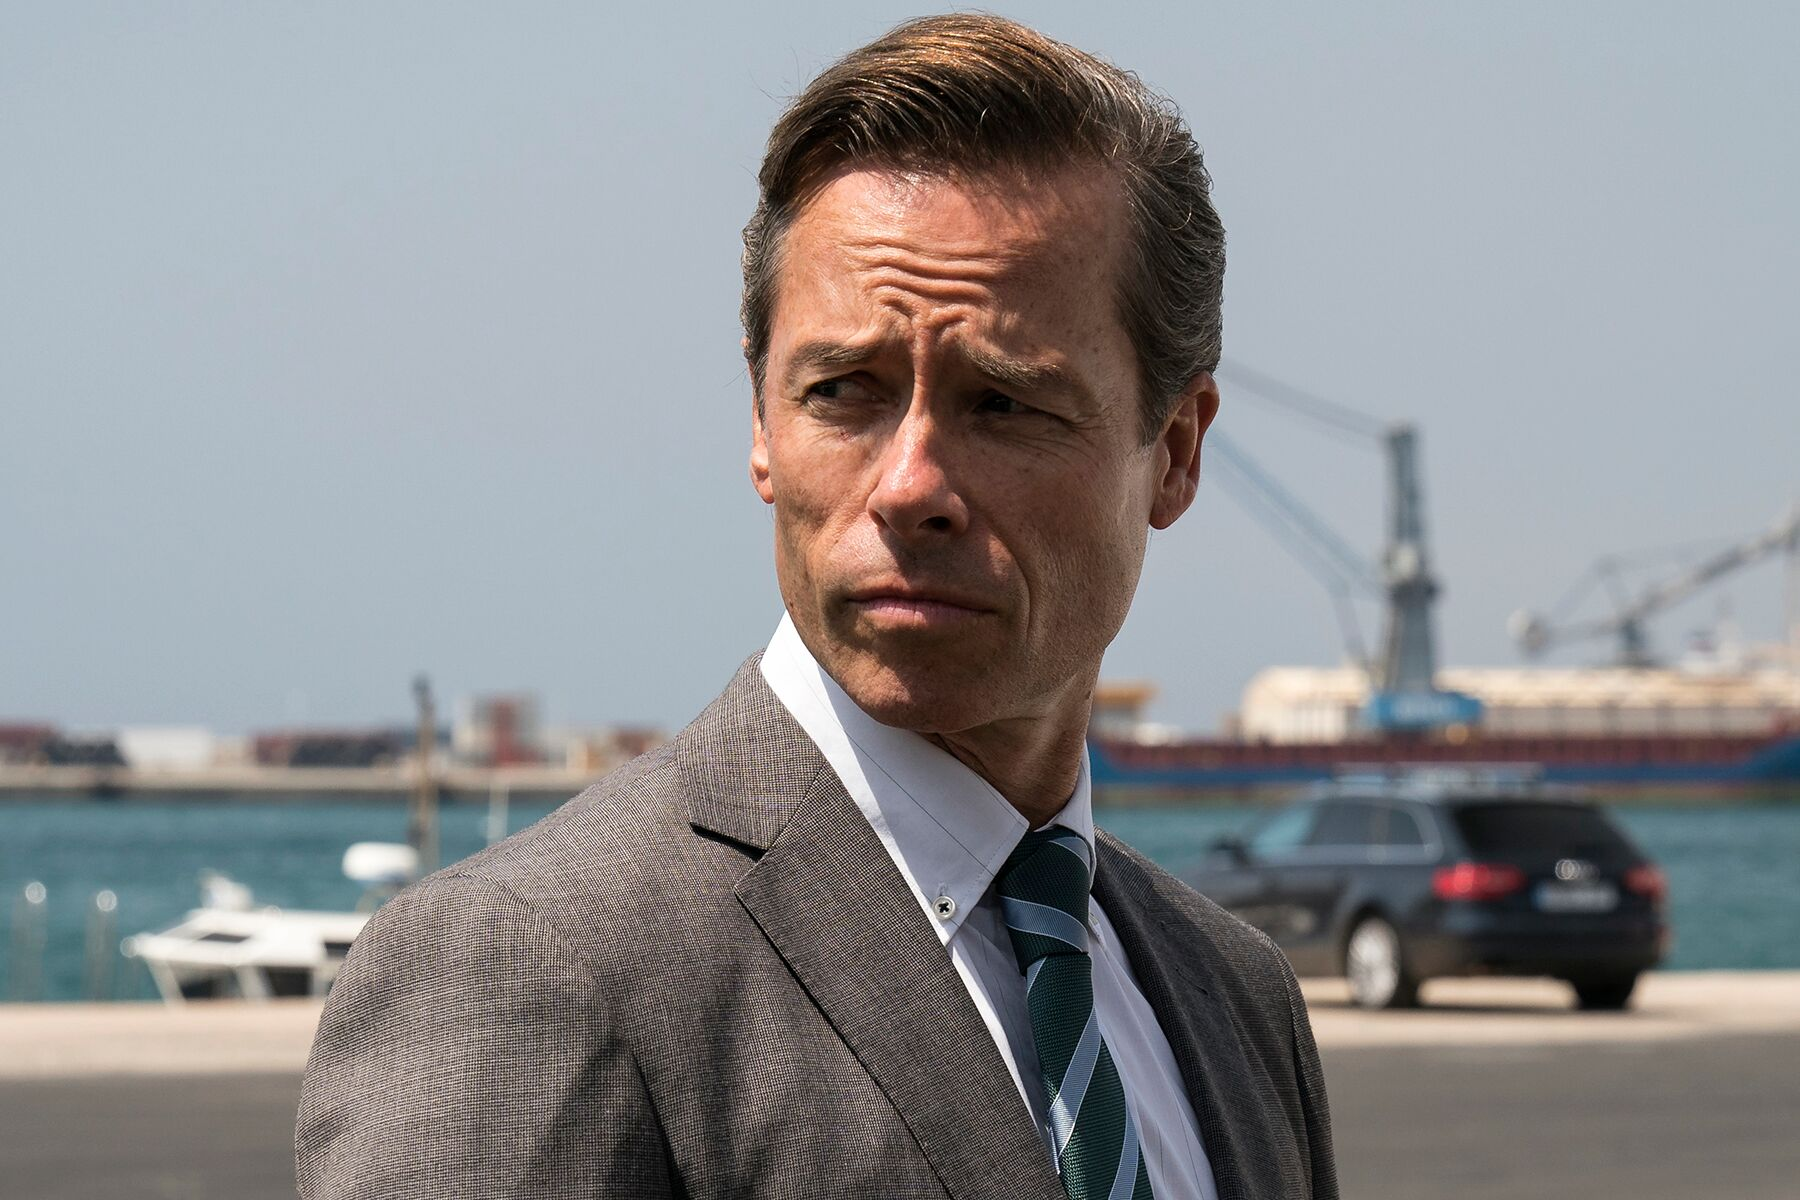Write a dialogue that could be happening in this scene. Assistant: "Sir, the shipment has arrived and is being unloaded as we speak."
Boss: "Good. I need a full report on any discrepancies." 
Assistant: "Understood. The CEO also wants a meeting tomorrow morning to discuss the next steps."
Boss: "Set it for 9 AM. We can't afford any delays." 
Assistant: "I'll notify them. Anything else?"
Boss: "Ensure all security protocols are followed. I don't want any surprises." 
Assistant: "Yes, sir. Everything will be checked thoroughly." 